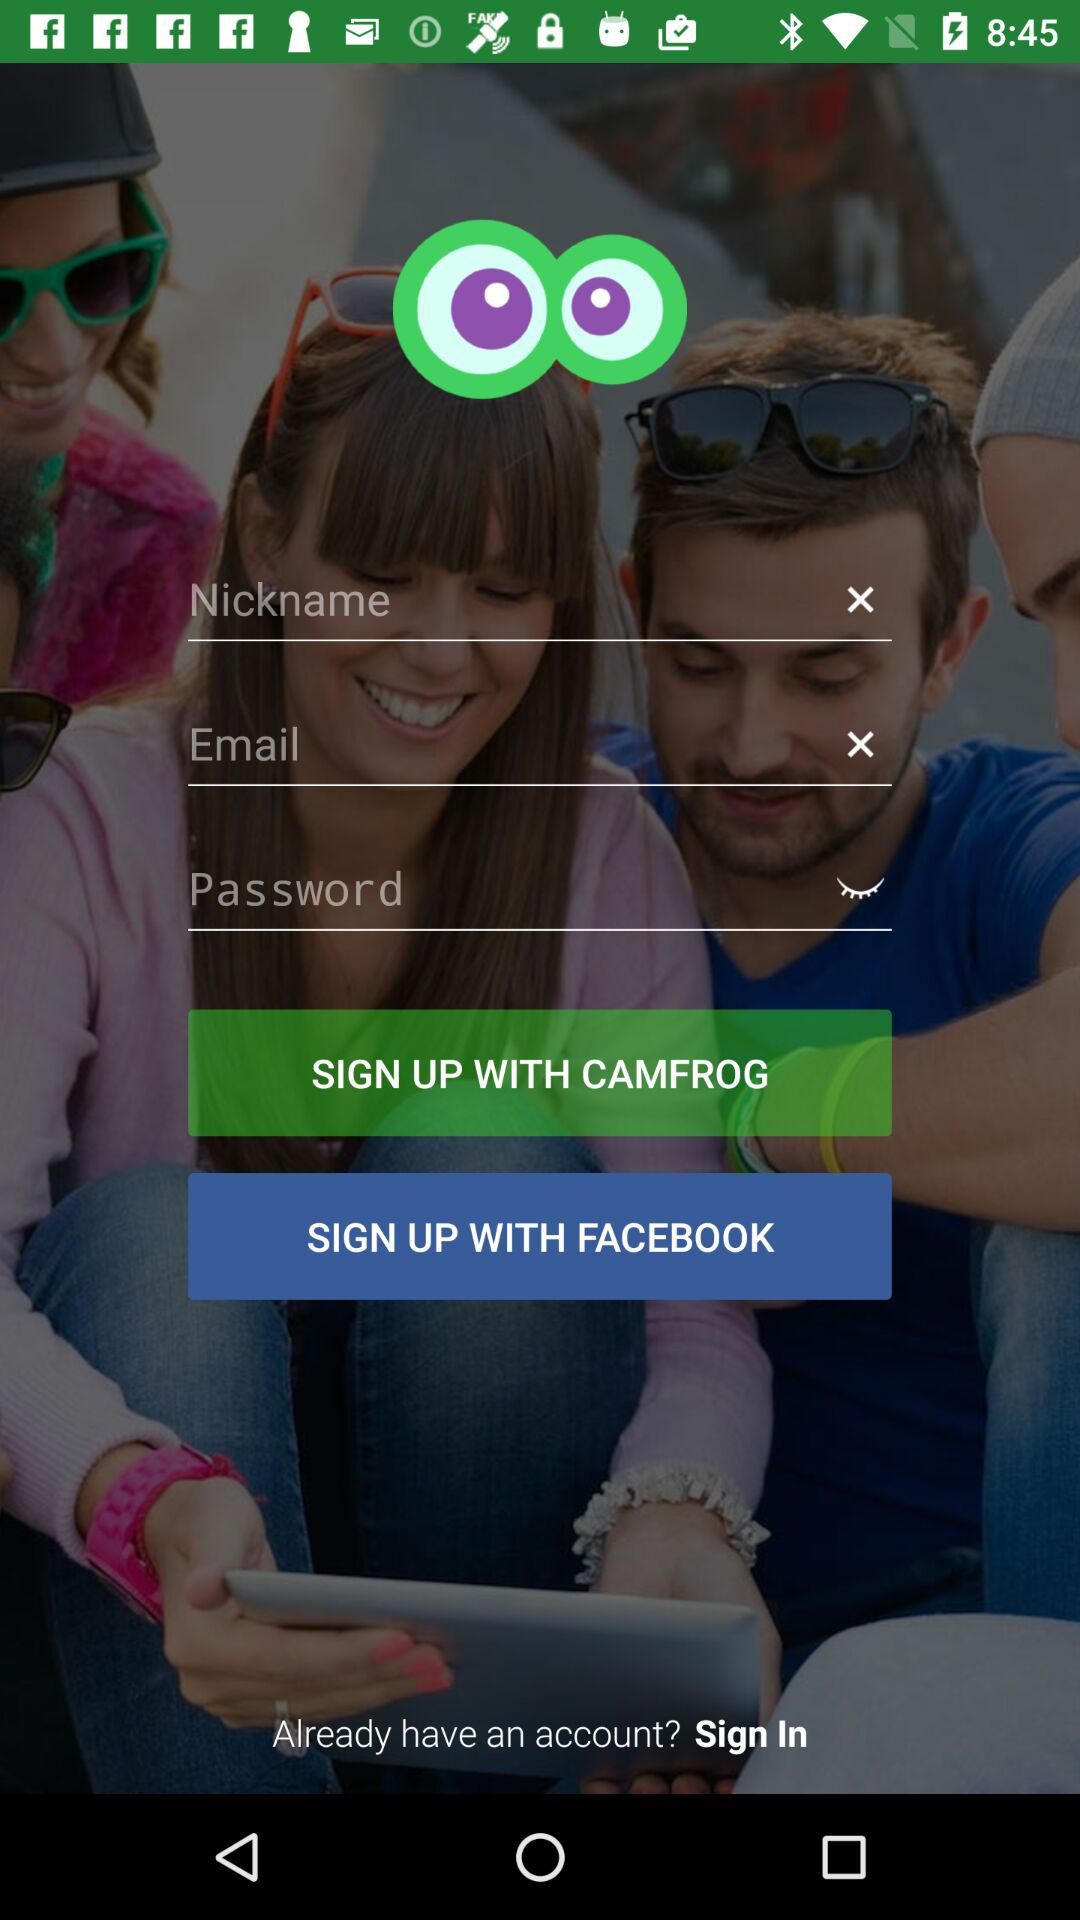How many text inputs are there for the sign up form?
Answer the question using a single word or phrase. 3 